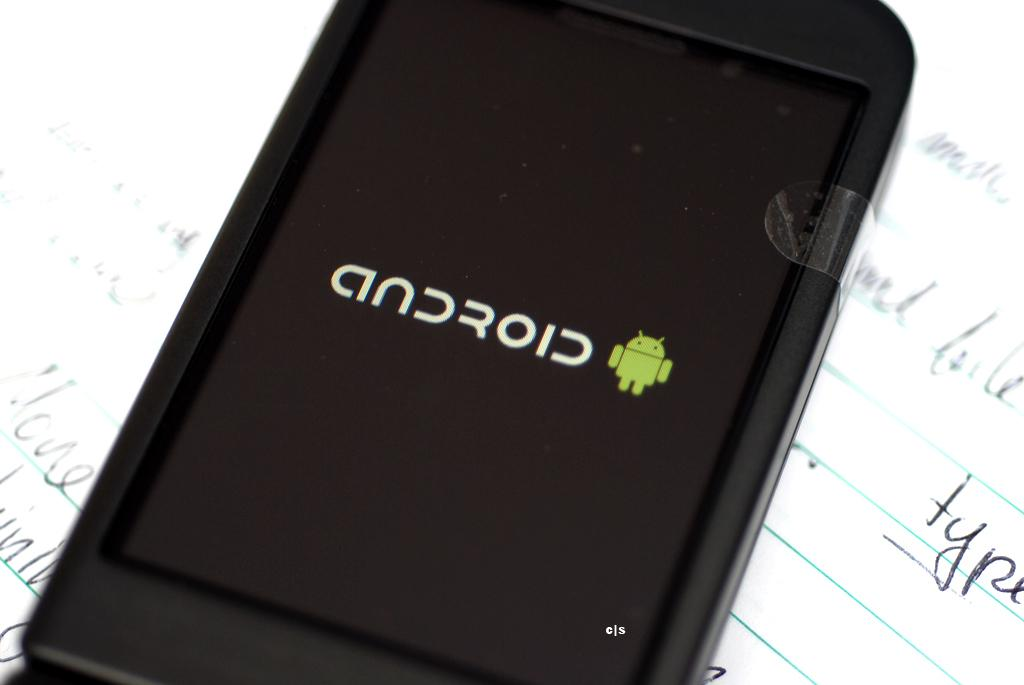<image>
Summarize the visual content of the image. A smartphone resting on a sheet of lined paper showing the android logo on its screen. 